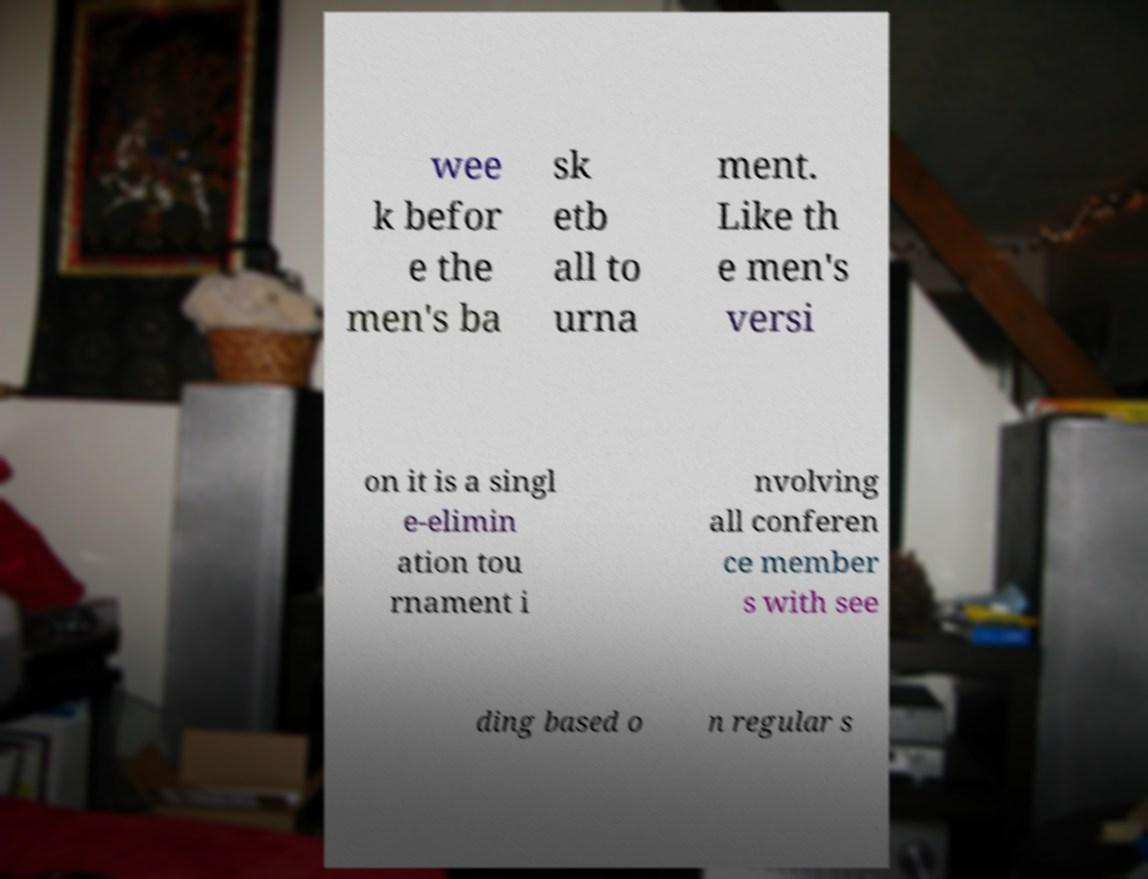Could you extract and type out the text from this image? wee k befor e the men's ba sk etb all to urna ment. Like th e men's versi on it is a singl e-elimin ation tou rnament i nvolving all conferen ce member s with see ding based o n regular s 